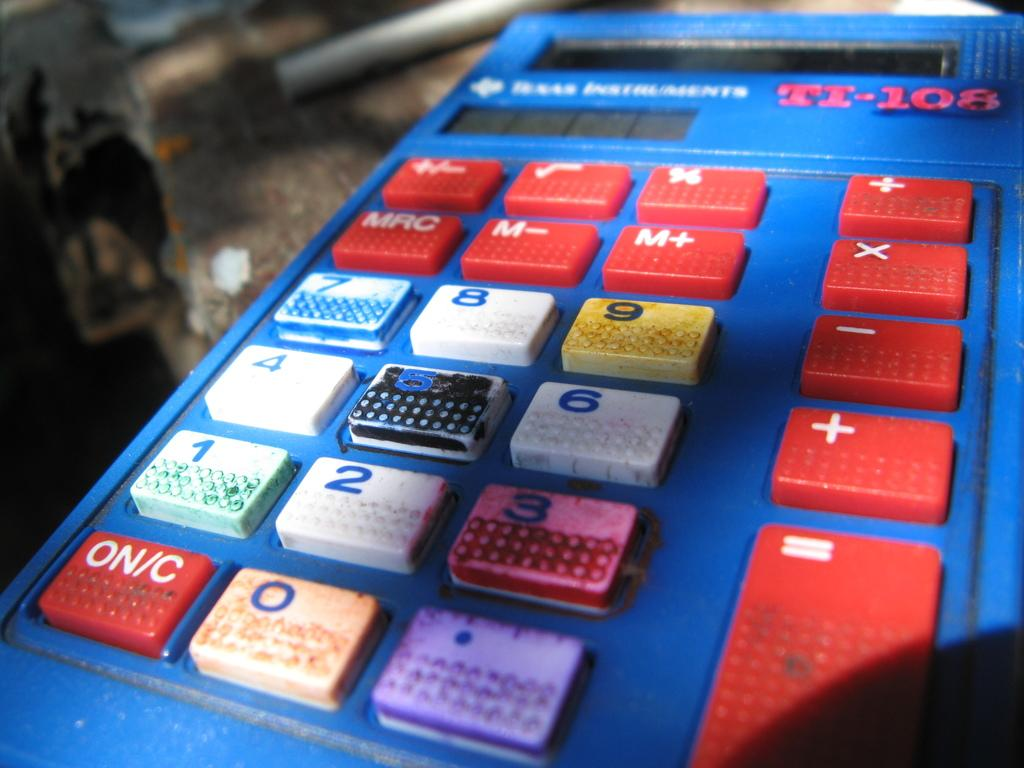What color is the calculator in the image? The calculator in the image is blue. Where is the calculator located in the image? The calculator is on a surface. Can you describe any other objects in the image? There is an object at the top of the image. What type of jelly is being used to hold the calculator in place in the image? There is no jelly present in the image, and the calculator is not being held in place by any jelly. 